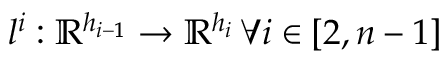<formula> <loc_0><loc_0><loc_500><loc_500>l ^ { i } \colon \mathbb { R } ^ { h _ { i - 1 } } \rightarrow \mathbb { R } ^ { h _ { i } } \, \forall i \in [ 2 , n - 1 ]</formula> 